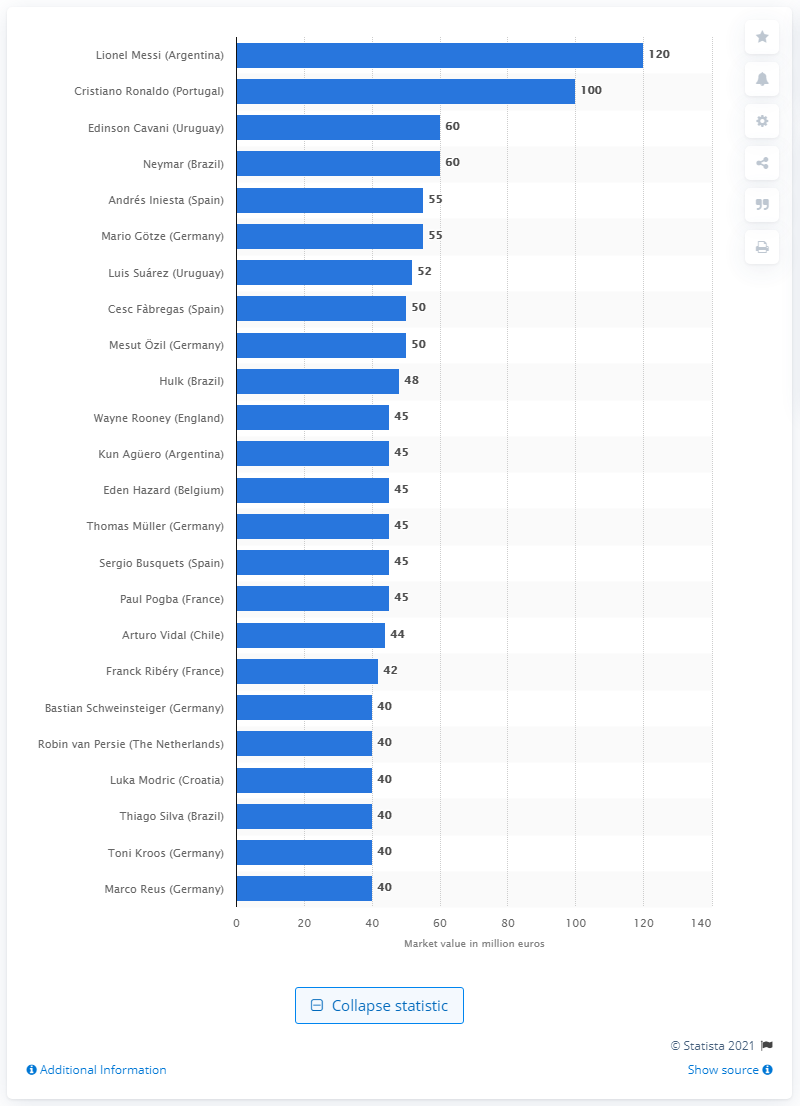Specify some key components in this picture. Lionel Messi's transfer market value is 120. 